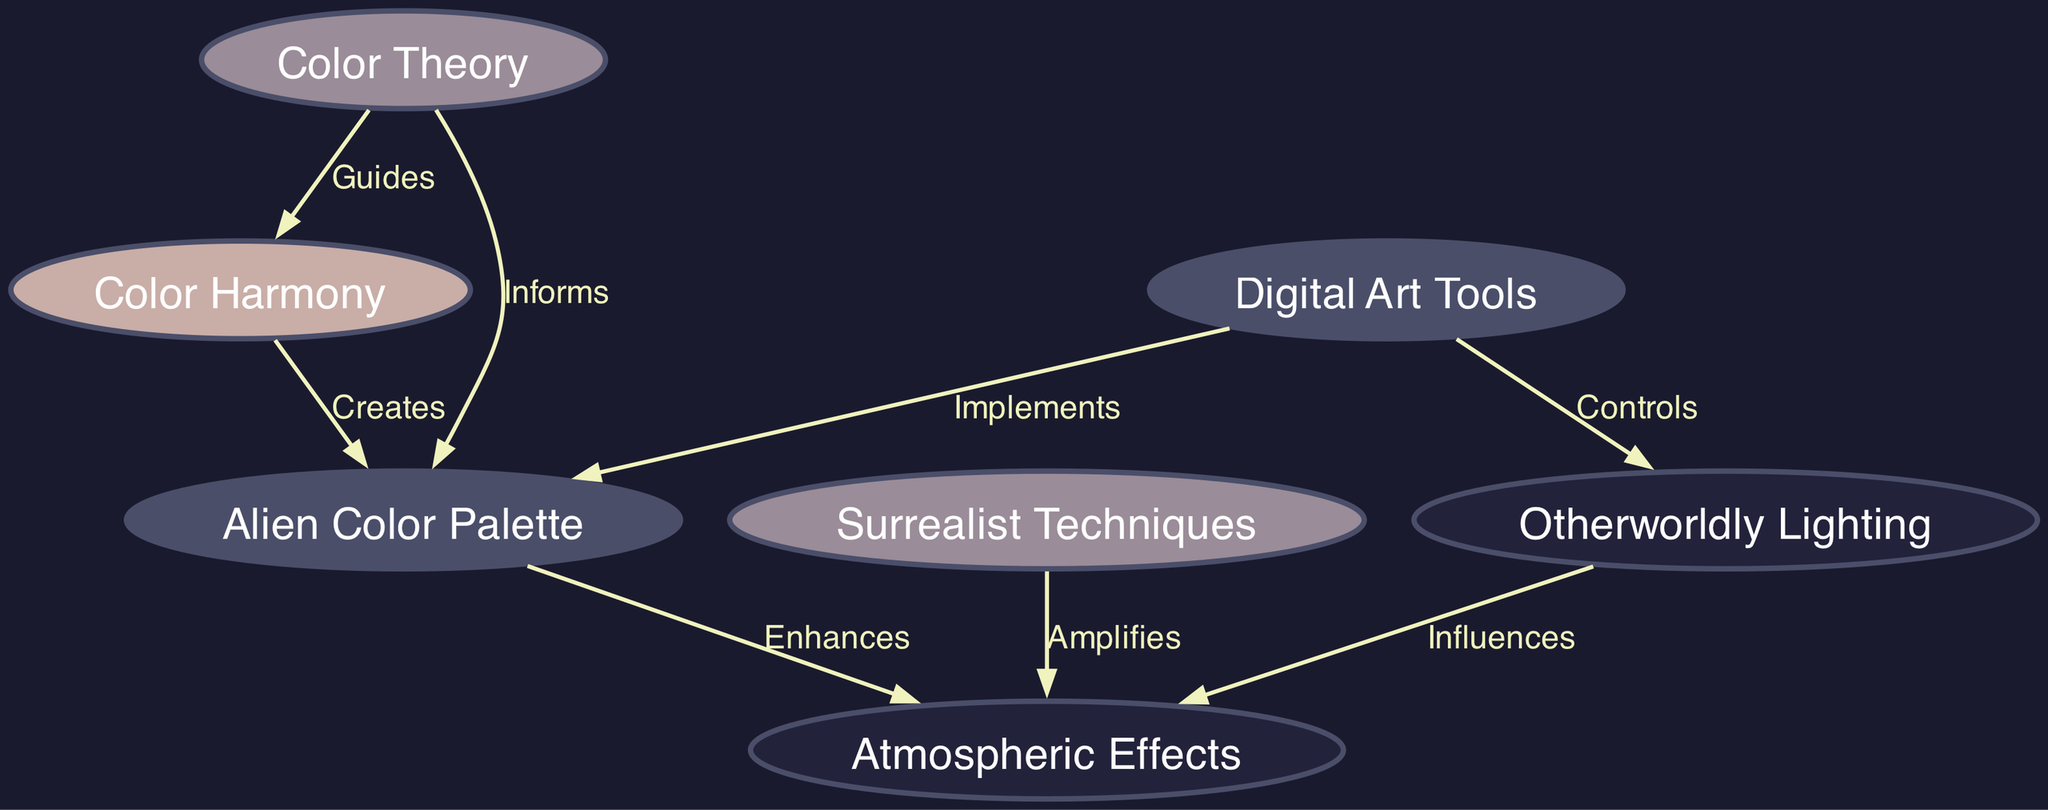What is the central theme of the diagram? The central theme is "Color Theory," which connects various aspects of color usage in creating alien landscapes in digital art.
Answer: Color Theory How many nodes are there in total? There are seven nodes representing different concepts related to color theory and its application.
Answer: 7 Which node directly influences "Alien Color Palette"? "Color Theory" informs the "Alien Color Palette" directly by providing foundational principles that guide its creation.
Answer: Color Theory What relationship exists between "Color Harmony" and "Alien Color Palette"? "Color Harmony" creates an "Alien Color Palette," showing that harmony is essential for crafting pleasing colors in this context.
Answer: Creates Which element enhances the "Atmospheric Effects"? The "Alien Color Palette" enhances the "Atmospheric Effects" by providing unique color combinations that affect mood and depth in the artwork.
Answer: Alien Color Palette How does "Surrealist Techniques" relate to "Atmospheric Effects"? "Surrealist Techniques" amplifies the "Atmospheric Effects," indicating the techniques enhance the visual impact of atmosphere in artwork.
Answer: Amplifies What does "Digital Art Tools" control in the diagram? "Digital Art Tools" controls "Otherworldly Lighting," emphasizing the importance of tools in managing light effects in digital art.
Answer: Otherworldly Lighting Which node guides the understanding of "Color Harmony"? "Color Theory" guides the understanding of "Color Harmony," suggesting that theory is essential for achieving harmony in colors.
Answer: Guides What color effect does "Lighting" have on "Atmospheric Effects"? "Lighting" influences "Atmospheric Effects," showing that lighting choices directly affect how the atmosphere feels in the artwork.
Answer: Influences 